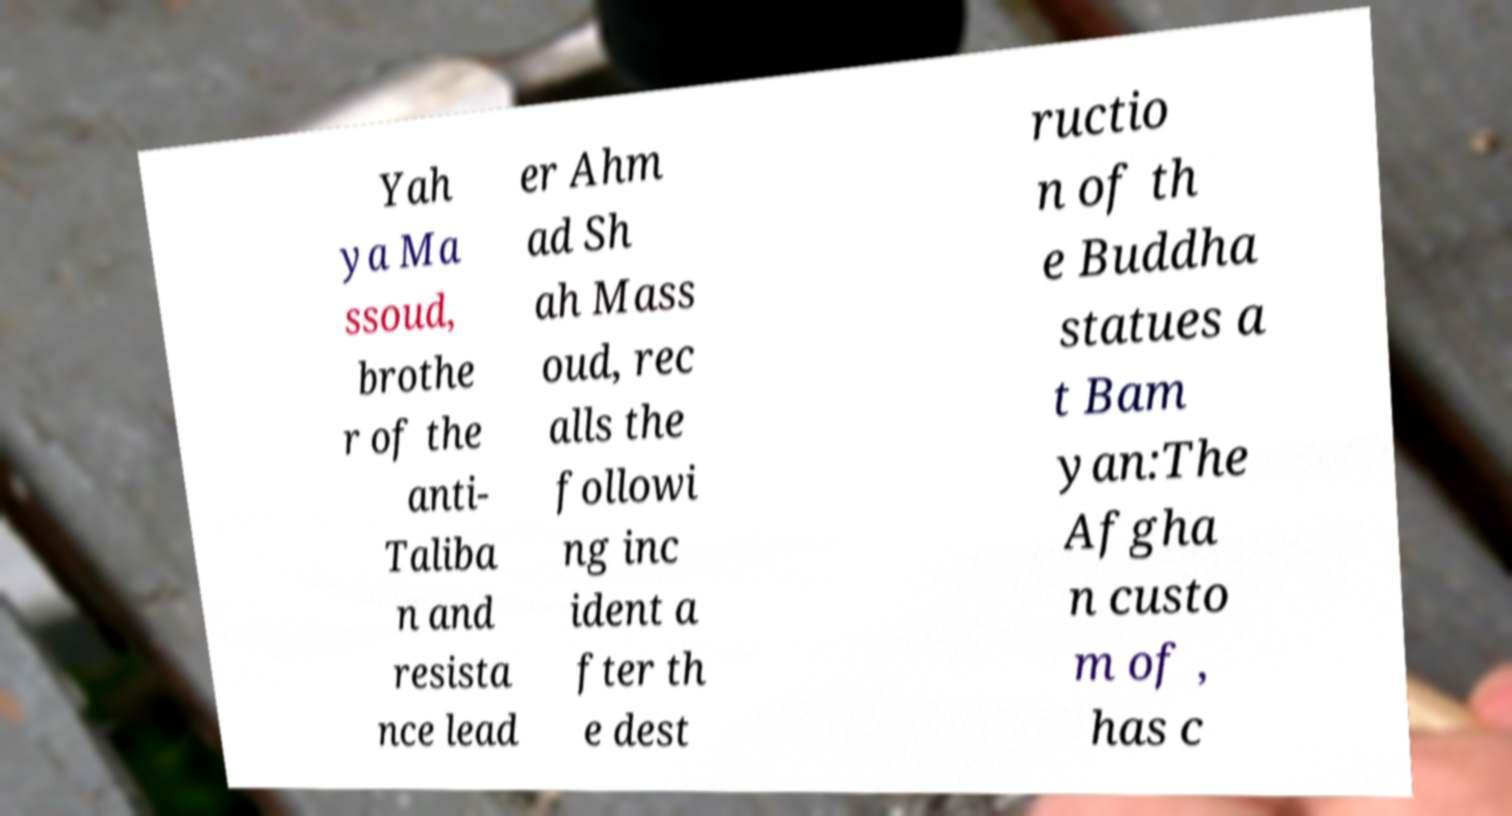Please read and relay the text visible in this image. What does it say? Yah ya Ma ssoud, brothe r of the anti- Taliba n and resista nce lead er Ahm ad Sh ah Mass oud, rec alls the followi ng inc ident a fter th e dest ructio n of th e Buddha statues a t Bam yan:The Afgha n custo m of , has c 